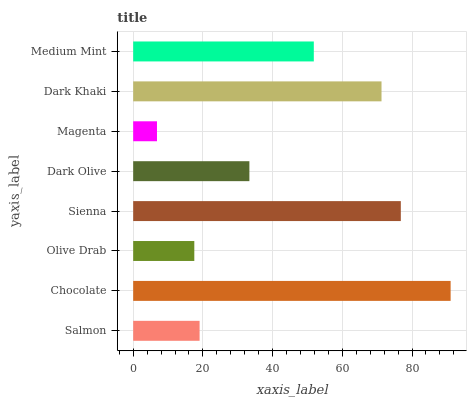Is Magenta the minimum?
Answer yes or no. Yes. Is Chocolate the maximum?
Answer yes or no. Yes. Is Olive Drab the minimum?
Answer yes or no. No. Is Olive Drab the maximum?
Answer yes or no. No. Is Chocolate greater than Olive Drab?
Answer yes or no. Yes. Is Olive Drab less than Chocolate?
Answer yes or no. Yes. Is Olive Drab greater than Chocolate?
Answer yes or no. No. Is Chocolate less than Olive Drab?
Answer yes or no. No. Is Medium Mint the high median?
Answer yes or no. Yes. Is Dark Olive the low median?
Answer yes or no. Yes. Is Chocolate the high median?
Answer yes or no. No. Is Magenta the low median?
Answer yes or no. No. 